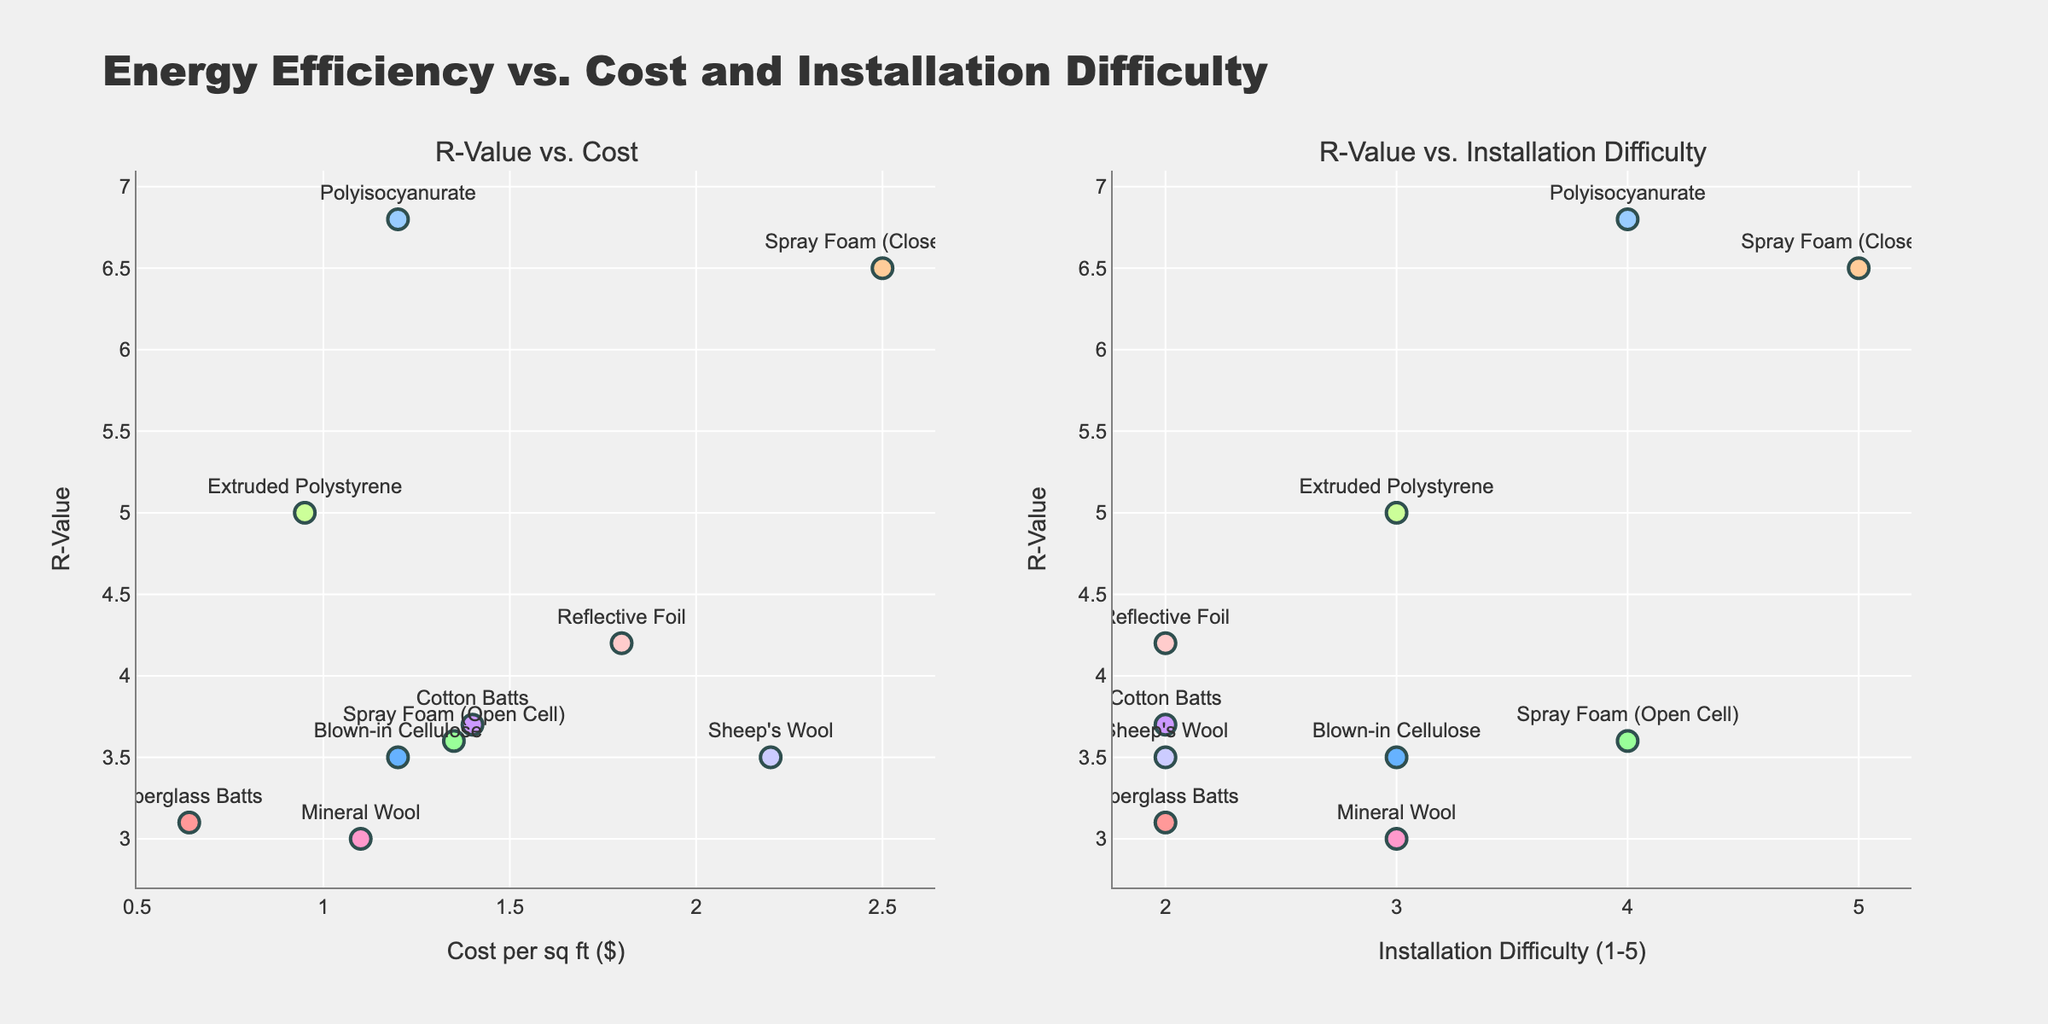What's the title of the figure? The title is typically displayed at the top of the figure. For this plot, it mentions "Energy Efficiency vs. Cost and Installation Difficulty". You can find it clearly stated above the subplots.
Answer: Energy Efficiency vs. Cost and Installation Difficulty How many materials are shown in the figure? By counting the number of distinct data points (markers) in the subplots, you will see that each marker corresponds to a different material. Both subplots contain the same number of markers.
Answer: 10 Which material has the highest R-Value? Look for the highest value on the y-axis in either of the subplots. The data label or hover text for that point will indicate the material.
Answer: Polyisocyanurate Which material has the lowest installation cost per square foot? Check the left subplot for the lowest value on the x-axis. The data label or hover text will indicate the material.
Answer: Fiberglass Batts What is the R-Value and installation difficulty of Spray Foam (Closed Cell)? Look for the marker labeled "Spray Foam (Closed Cell)" in the right subplot. The y-position will show the R-Value, and the x-position will show the installation difficulty.
Answer: R-Value: 6.5, Installation Difficulty: 5 How does the R-Value of Mineral Wool compare to Fiberglass Batts? Find the markers for both materials in either of the subplots and compare their y-axis positions.
Answer: R-Value of Mineral Wool is 3, which is slightly lower than Fiberglass Batts (3.1) Which material is the most difficult to install? Check the right subplot for the highest value on the x-axis. The data label or hover text will indicate the material.
Answer: Spray Foam (Closed Cell) What is the average R-Value of materials with installation difficulty of 3? Locate the markers with an installation difficulty of 3 in the right subplot, read their R-Values, and calculate the average: Blown-in Cellulose (3.5), Mineral Wool (3), Extruded Polystyrene (5). Average = (3.5 + 3 + 5)/3 = 3.83
Answer: 3.83 Which material is the most expensive to install per square foot, and what is its R-Value? Check the left subplot for the highest value on the x-axis. The data label or hover text will indicate the material and its corresponding R-Value.
Answer: Spray Foam (Closed Cell), R-Value: 6.5 